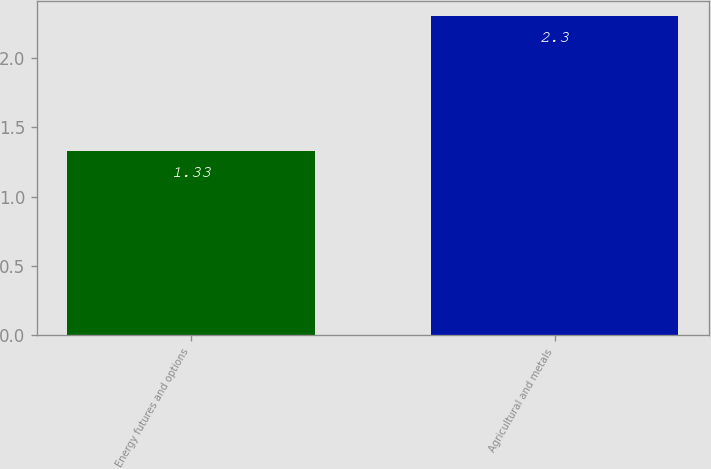<chart> <loc_0><loc_0><loc_500><loc_500><bar_chart><fcel>Energy futures and options<fcel>Agricultural and metals<nl><fcel>1.33<fcel>2.3<nl></chart> 